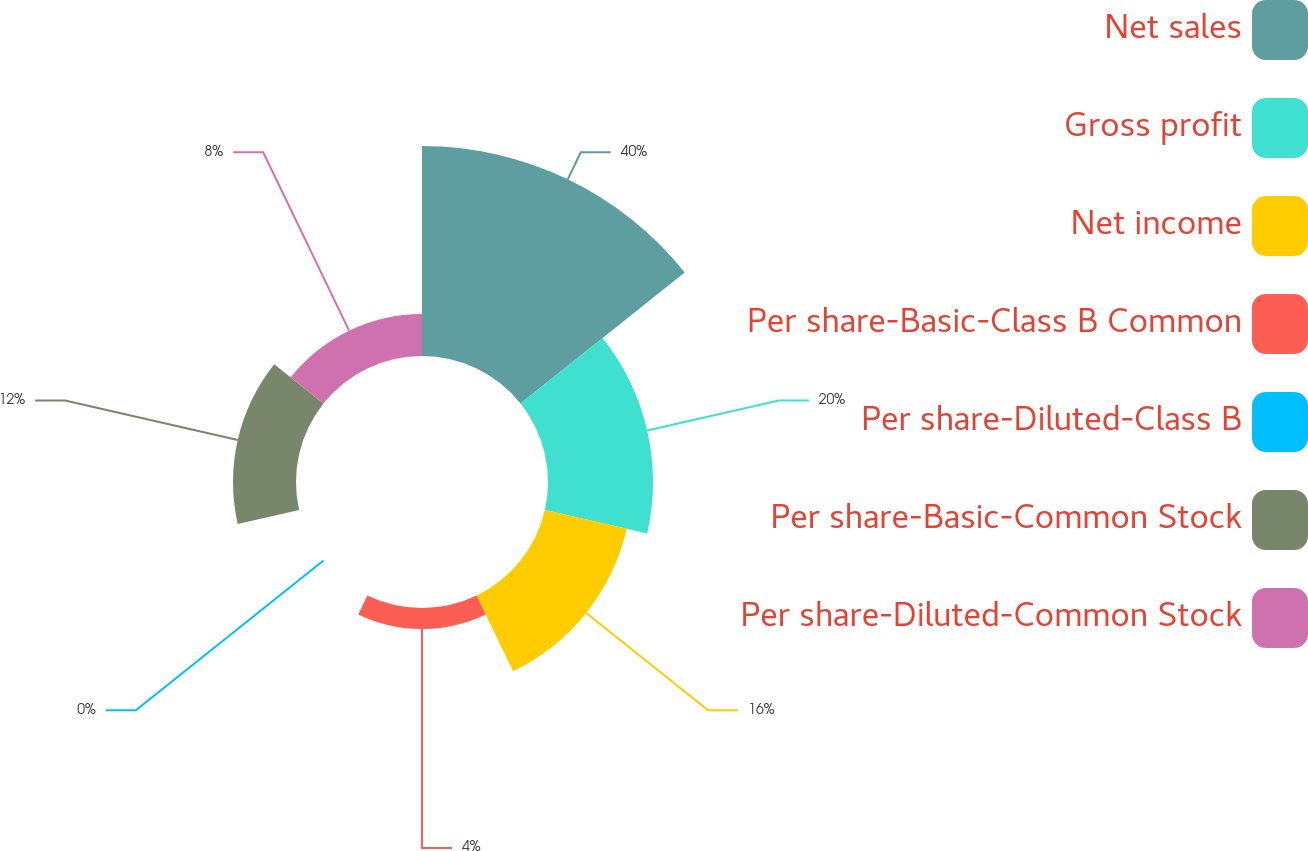Convert chart. <chart><loc_0><loc_0><loc_500><loc_500><pie_chart><fcel>Net sales<fcel>Gross profit<fcel>Net income<fcel>Per share-Basic-Class B Common<fcel>Per share-Diluted-Class B<fcel>Per share-Basic-Common Stock<fcel>Per share-Diluted-Common Stock<nl><fcel>40.0%<fcel>20.0%<fcel>16.0%<fcel>4.0%<fcel>0.0%<fcel>12.0%<fcel>8.0%<nl></chart> 